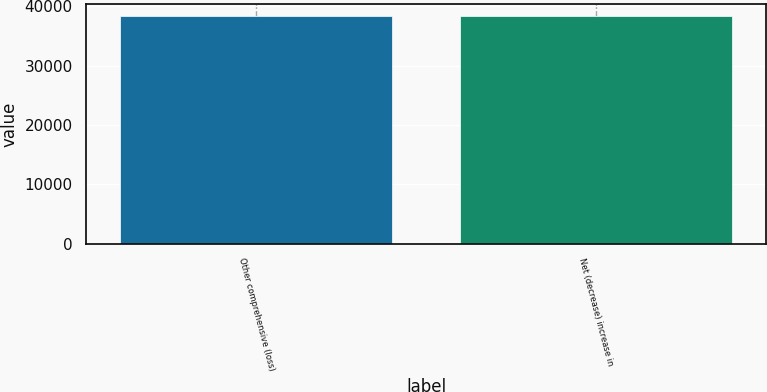Convert chart. <chart><loc_0><loc_0><loc_500><loc_500><bar_chart><fcel>Other comprehensive (loss)<fcel>Net (decrease) increase in<nl><fcel>38386<fcel>38386.1<nl></chart> 